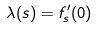<formula> <loc_0><loc_0><loc_500><loc_500>\lambda ( s ) = f _ { s } ^ { \prime } ( 0 )</formula> 